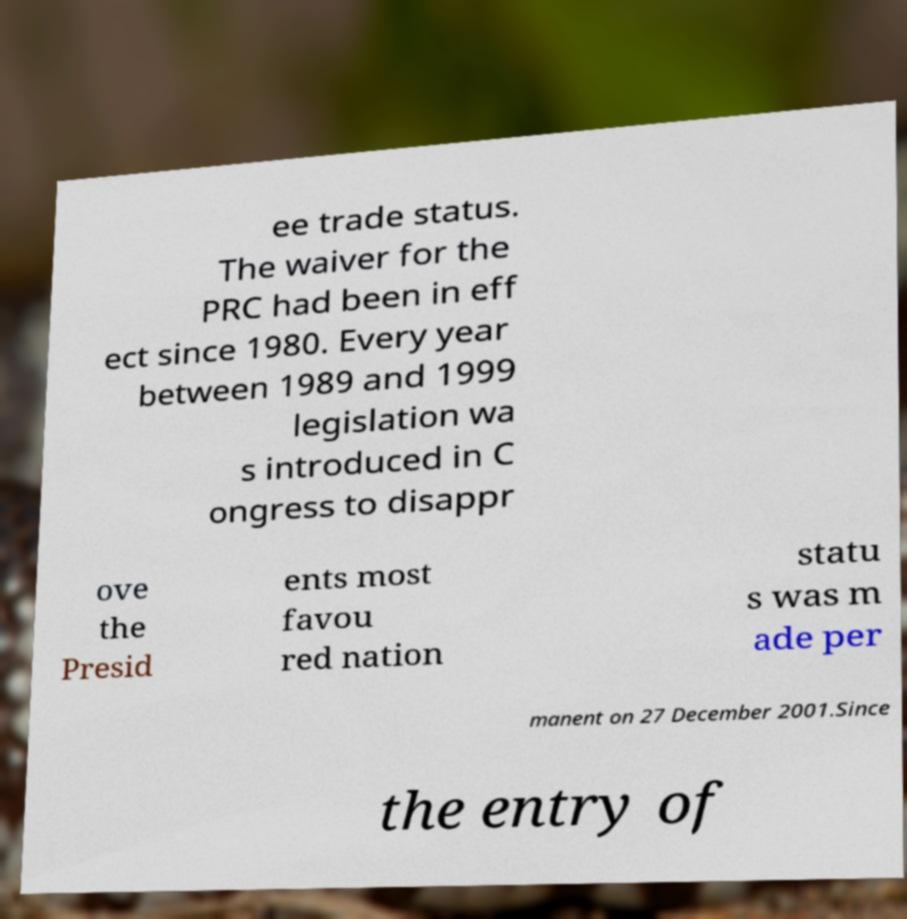Could you assist in decoding the text presented in this image and type it out clearly? ee trade status. The waiver for the PRC had been in eff ect since 1980. Every year between 1989 and 1999 legislation wa s introduced in C ongress to disappr ove the Presid ents most favou red nation statu s was m ade per manent on 27 December 2001.Since the entry of 